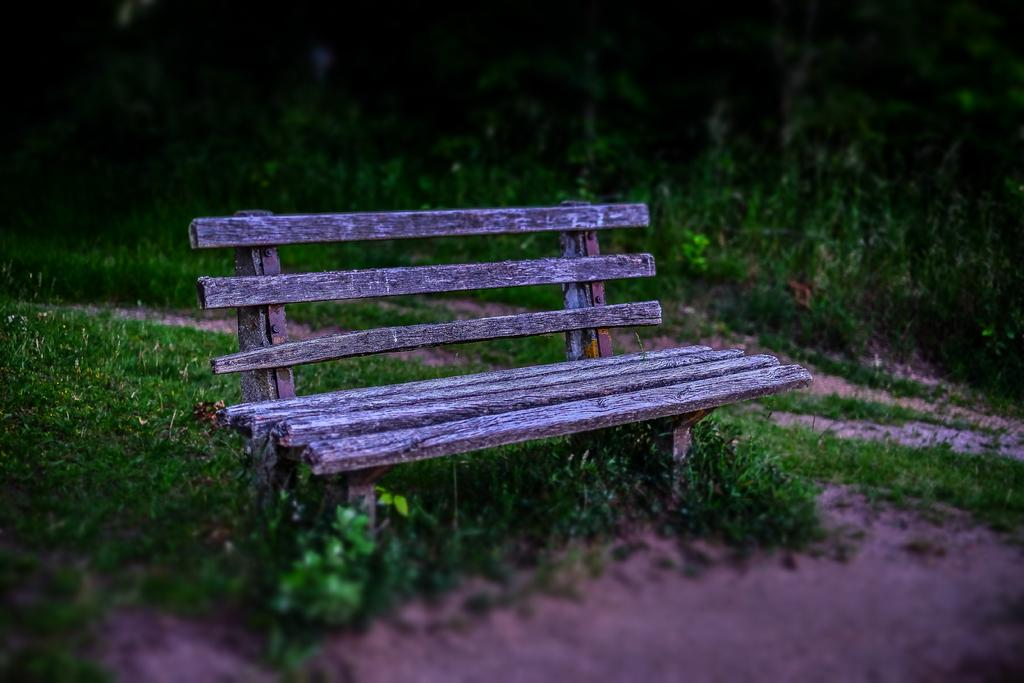What type of seating is visible in the image? There is a bench in the image. Where is the bench located? The bench is on the ground. What type of vegetation can be seen in the image? There are plants in the image. What type of ground cover is present in the image? There is grass in the image. What type of school can be seen in the image? There is no school present in the image. How many geese are visible in the image? There are no geese present in the image. 